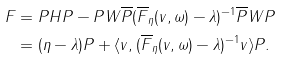Convert formula to latex. <formula><loc_0><loc_0><loc_500><loc_500>F & = P H P - P W \overline { P } ( \overline { F } _ { \eta } ( v , \omega ) - \lambda ) ^ { - 1 } \overline { P } W P \\ & = ( \eta - \lambda ) P + \langle v , ( \overline { F } _ { \eta } ( v , \omega ) - \lambda ) ^ { - 1 } v \rangle P .</formula> 